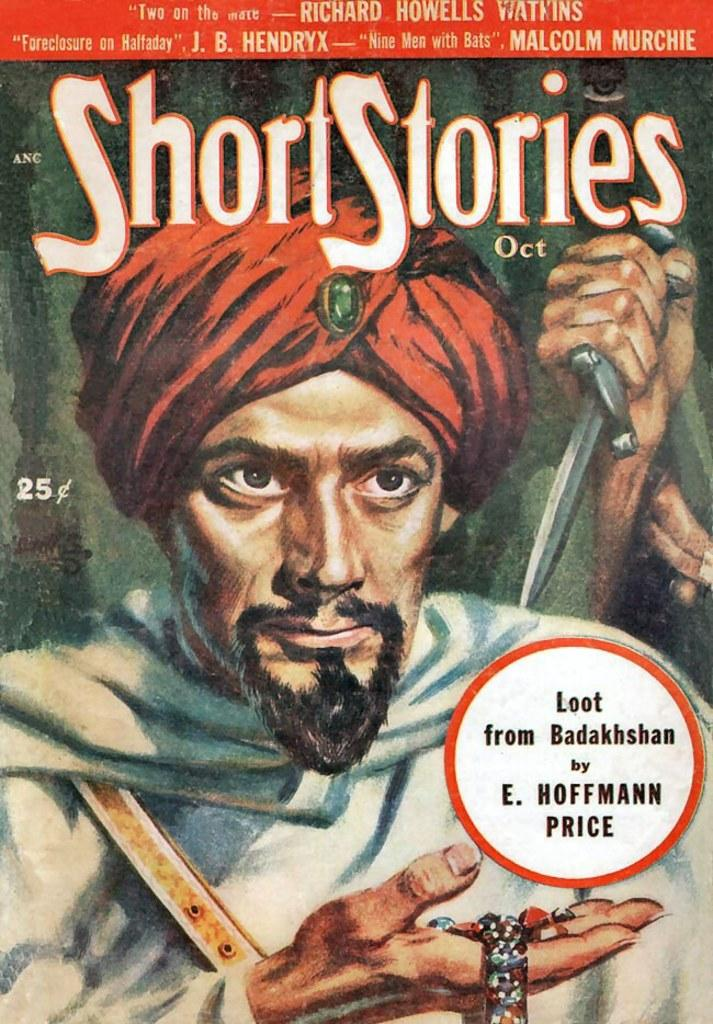What type of business is being conducted in the image? The image is animated, and there is no reference to a business in the provided facts. --- 